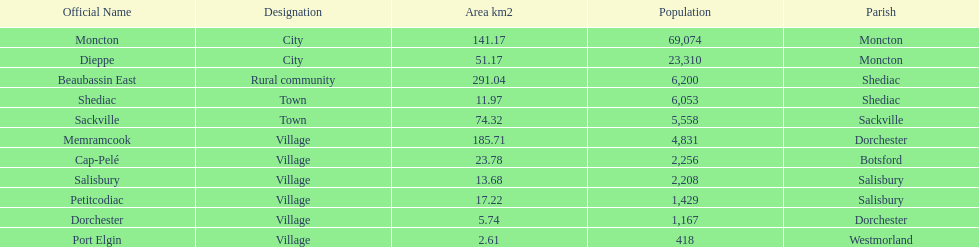The only rural community on the list Beaubassin East. 